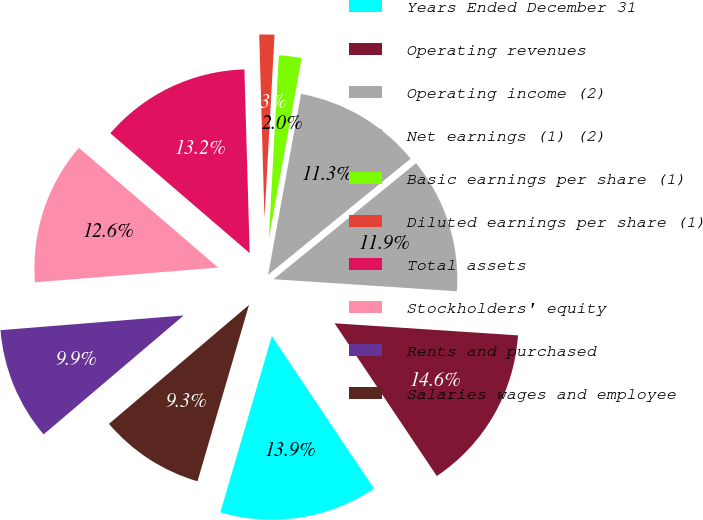<chart> <loc_0><loc_0><loc_500><loc_500><pie_chart><fcel>Years Ended December 31<fcel>Operating revenues<fcel>Operating income (2)<fcel>Net earnings (1) (2)<fcel>Basic earnings per share (1)<fcel>Diluted earnings per share (1)<fcel>Total assets<fcel>Stockholders' equity<fcel>Rents and purchased<fcel>Salaries wages and employee<nl><fcel>13.91%<fcel>14.57%<fcel>11.92%<fcel>11.26%<fcel>1.99%<fcel>1.33%<fcel>13.24%<fcel>12.58%<fcel>9.93%<fcel>9.27%<nl></chart> 